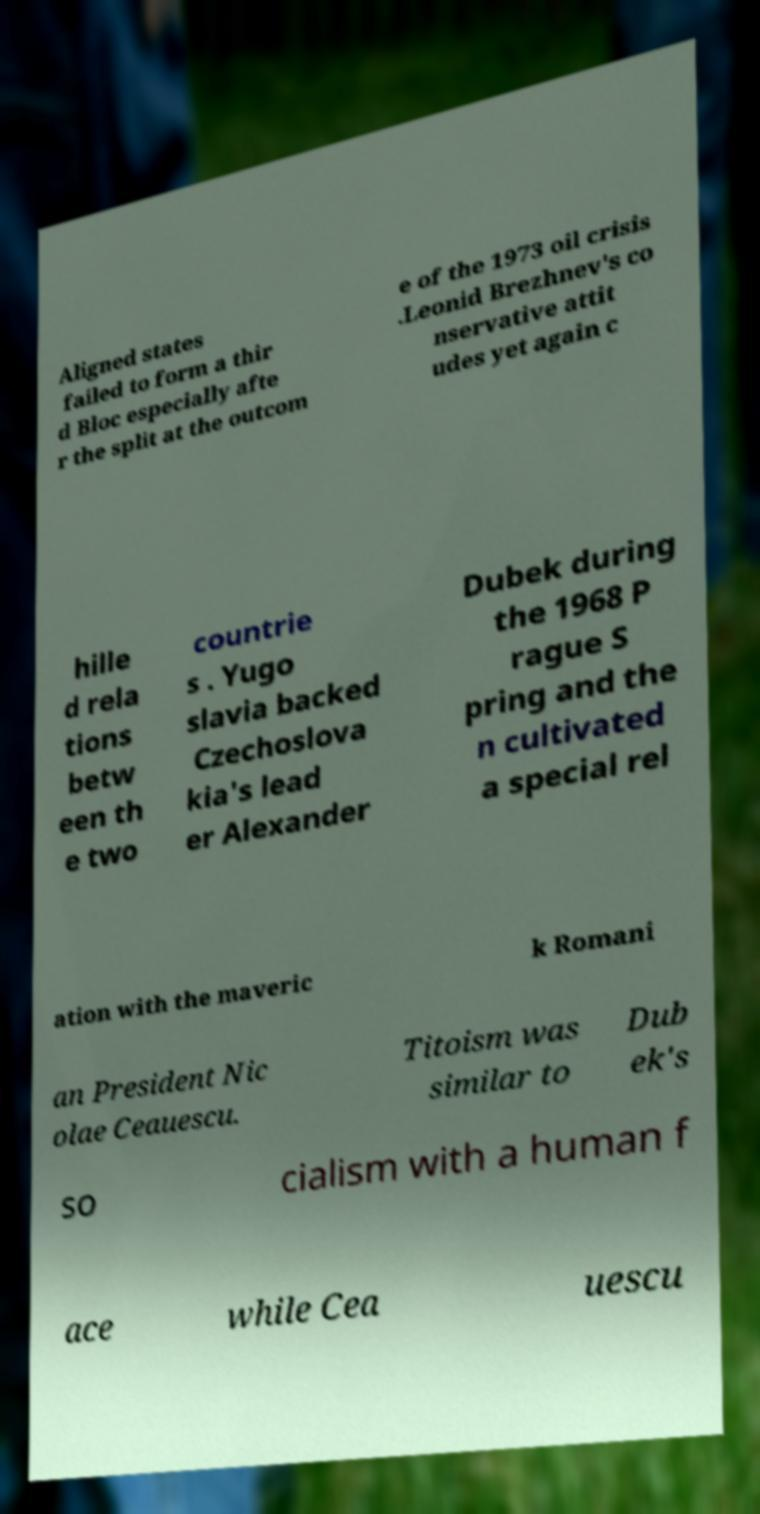For documentation purposes, I need the text within this image transcribed. Could you provide that? Aligned states failed to form a thir d Bloc especially afte r the split at the outcom e of the 1973 oil crisis .Leonid Brezhnev's co nservative attit udes yet again c hille d rela tions betw een th e two countrie s . Yugo slavia backed Czechoslova kia's lead er Alexander Dubek during the 1968 P rague S pring and the n cultivated a special rel ation with the maveric k Romani an President Nic olae Ceauescu. Titoism was similar to Dub ek's so cialism with a human f ace while Cea uescu 